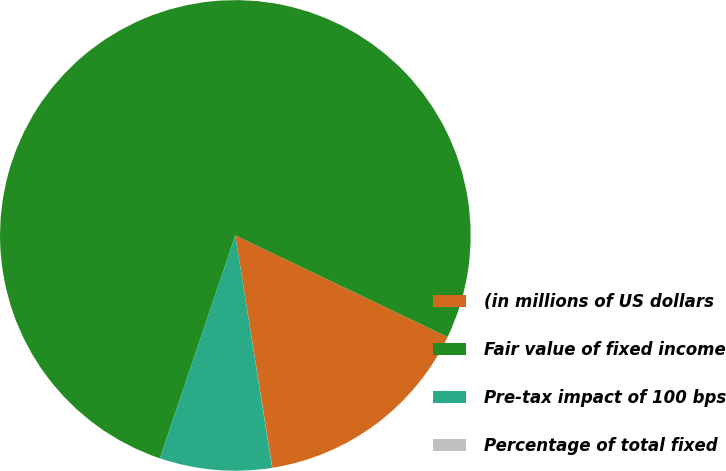Convert chart to OTSL. <chart><loc_0><loc_0><loc_500><loc_500><pie_chart><fcel>(in millions of US dollars<fcel>Fair value of fixed income<fcel>Pre-tax impact of 100 bps<fcel>Percentage of total fixed<nl><fcel>15.39%<fcel>76.91%<fcel>7.7%<fcel>0.01%<nl></chart> 